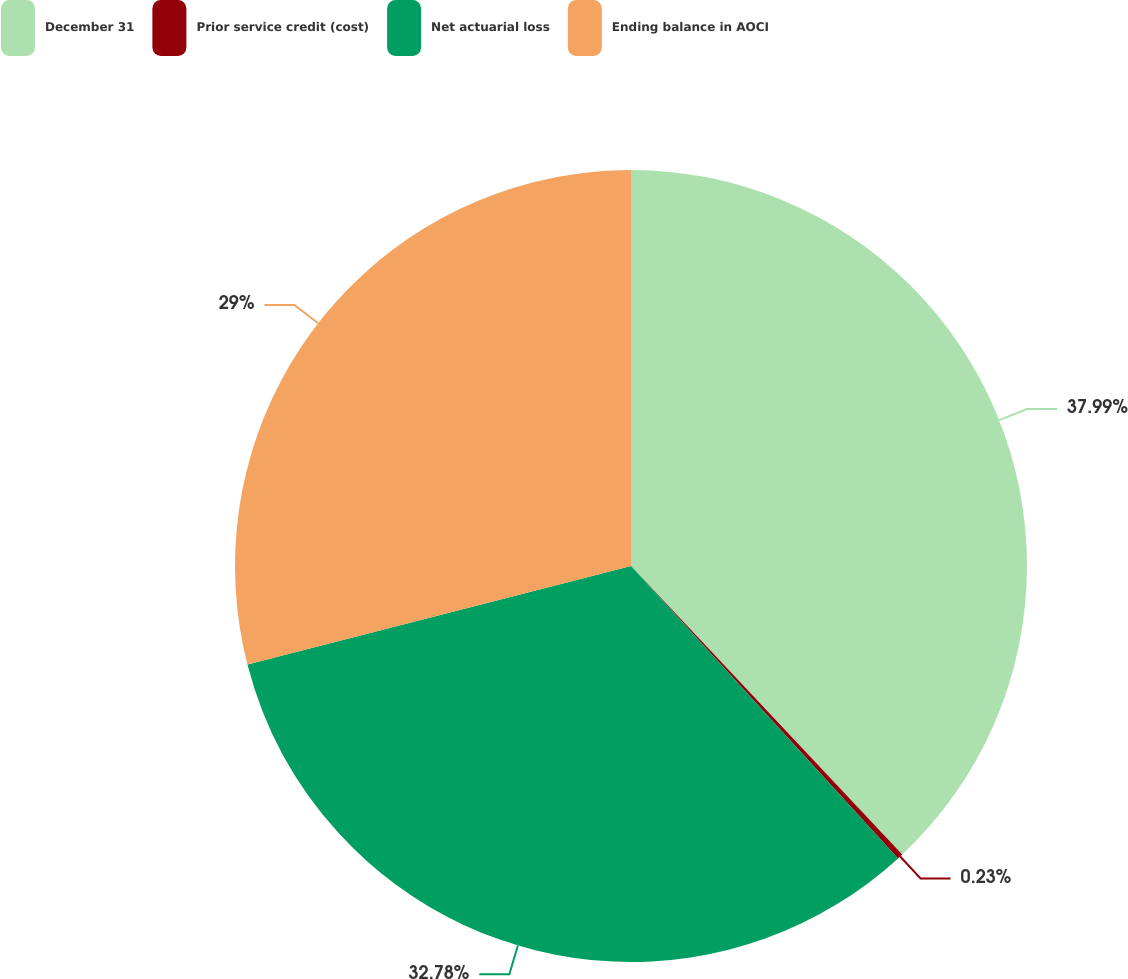Convert chart to OTSL. <chart><loc_0><loc_0><loc_500><loc_500><pie_chart><fcel>December 31<fcel>Prior service credit (cost)<fcel>Net actuarial loss<fcel>Ending balance in AOCI<nl><fcel>37.99%<fcel>0.23%<fcel>32.78%<fcel>29.0%<nl></chart> 